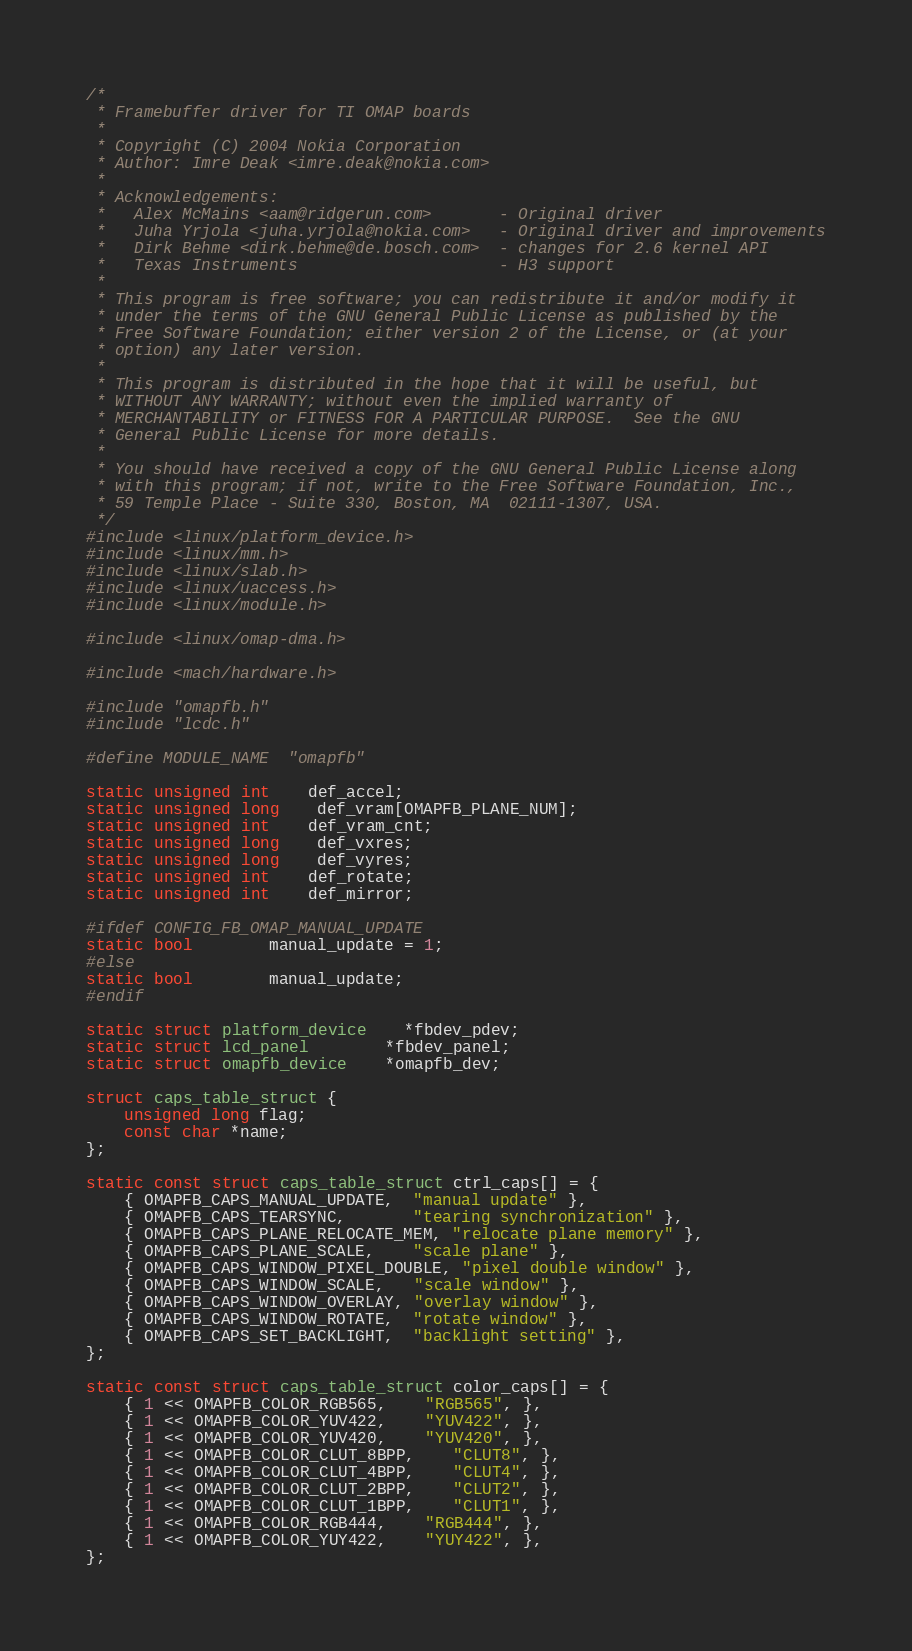Convert code to text. <code><loc_0><loc_0><loc_500><loc_500><_C_>/*
 * Framebuffer driver for TI OMAP boards
 *
 * Copyright (C) 2004 Nokia Corporation
 * Author: Imre Deak <imre.deak@nokia.com>
 *
 * Acknowledgements:
 *   Alex McMains <aam@ridgerun.com>       - Original driver
 *   Juha Yrjola <juha.yrjola@nokia.com>   - Original driver and improvements
 *   Dirk Behme <dirk.behme@de.bosch.com>  - changes for 2.6 kernel API
 *   Texas Instruments                     - H3 support
 *
 * This program is free software; you can redistribute it and/or modify it
 * under the terms of the GNU General Public License as published by the
 * Free Software Foundation; either version 2 of the License, or (at your
 * option) any later version.
 *
 * This program is distributed in the hope that it will be useful, but
 * WITHOUT ANY WARRANTY; without even the implied warranty of
 * MERCHANTABILITY or FITNESS FOR A PARTICULAR PURPOSE.  See the GNU
 * General Public License for more details.
 *
 * You should have received a copy of the GNU General Public License along
 * with this program; if not, write to the Free Software Foundation, Inc.,
 * 59 Temple Place - Suite 330, Boston, MA  02111-1307, USA.
 */
#include <linux/platform_device.h>
#include <linux/mm.h>
#include <linux/slab.h>
#include <linux/uaccess.h>
#include <linux/module.h>

#include <linux/omap-dma.h>

#include <mach/hardware.h>

#include "omapfb.h"
#include "lcdc.h"

#define MODULE_NAME	"omapfb"

static unsigned int	def_accel;
static unsigned long	def_vram[OMAPFB_PLANE_NUM];
static unsigned int	def_vram_cnt;
static unsigned long	def_vxres;
static unsigned long	def_vyres;
static unsigned int	def_rotate;
static unsigned int	def_mirror;

#ifdef CONFIG_FB_OMAP_MANUAL_UPDATE
static bool		manual_update = 1;
#else
static bool		manual_update;
#endif

static struct platform_device	*fbdev_pdev;
static struct lcd_panel		*fbdev_panel;
static struct omapfb_device	*omapfb_dev;

struct caps_table_struct {
	unsigned long flag;
	const char *name;
};

static const struct caps_table_struct ctrl_caps[] = {
	{ OMAPFB_CAPS_MANUAL_UPDATE,  "manual update" },
	{ OMAPFB_CAPS_TEARSYNC,       "tearing synchronization" },
	{ OMAPFB_CAPS_PLANE_RELOCATE_MEM, "relocate plane memory" },
	{ OMAPFB_CAPS_PLANE_SCALE,    "scale plane" },
	{ OMAPFB_CAPS_WINDOW_PIXEL_DOUBLE, "pixel double window" },
	{ OMAPFB_CAPS_WINDOW_SCALE,   "scale window" },
	{ OMAPFB_CAPS_WINDOW_OVERLAY, "overlay window" },
	{ OMAPFB_CAPS_WINDOW_ROTATE,  "rotate window" },
	{ OMAPFB_CAPS_SET_BACKLIGHT,  "backlight setting" },
};

static const struct caps_table_struct color_caps[] = {
	{ 1 << OMAPFB_COLOR_RGB565,	"RGB565", },
	{ 1 << OMAPFB_COLOR_YUV422,	"YUV422", },
	{ 1 << OMAPFB_COLOR_YUV420,	"YUV420", },
	{ 1 << OMAPFB_COLOR_CLUT_8BPP,	"CLUT8", },
	{ 1 << OMAPFB_COLOR_CLUT_4BPP,	"CLUT4", },
	{ 1 << OMAPFB_COLOR_CLUT_2BPP,	"CLUT2", },
	{ 1 << OMAPFB_COLOR_CLUT_1BPP,	"CLUT1", },
	{ 1 << OMAPFB_COLOR_RGB444,	"RGB444", },
	{ 1 << OMAPFB_COLOR_YUY422,	"YUY422", },
};
</code> 